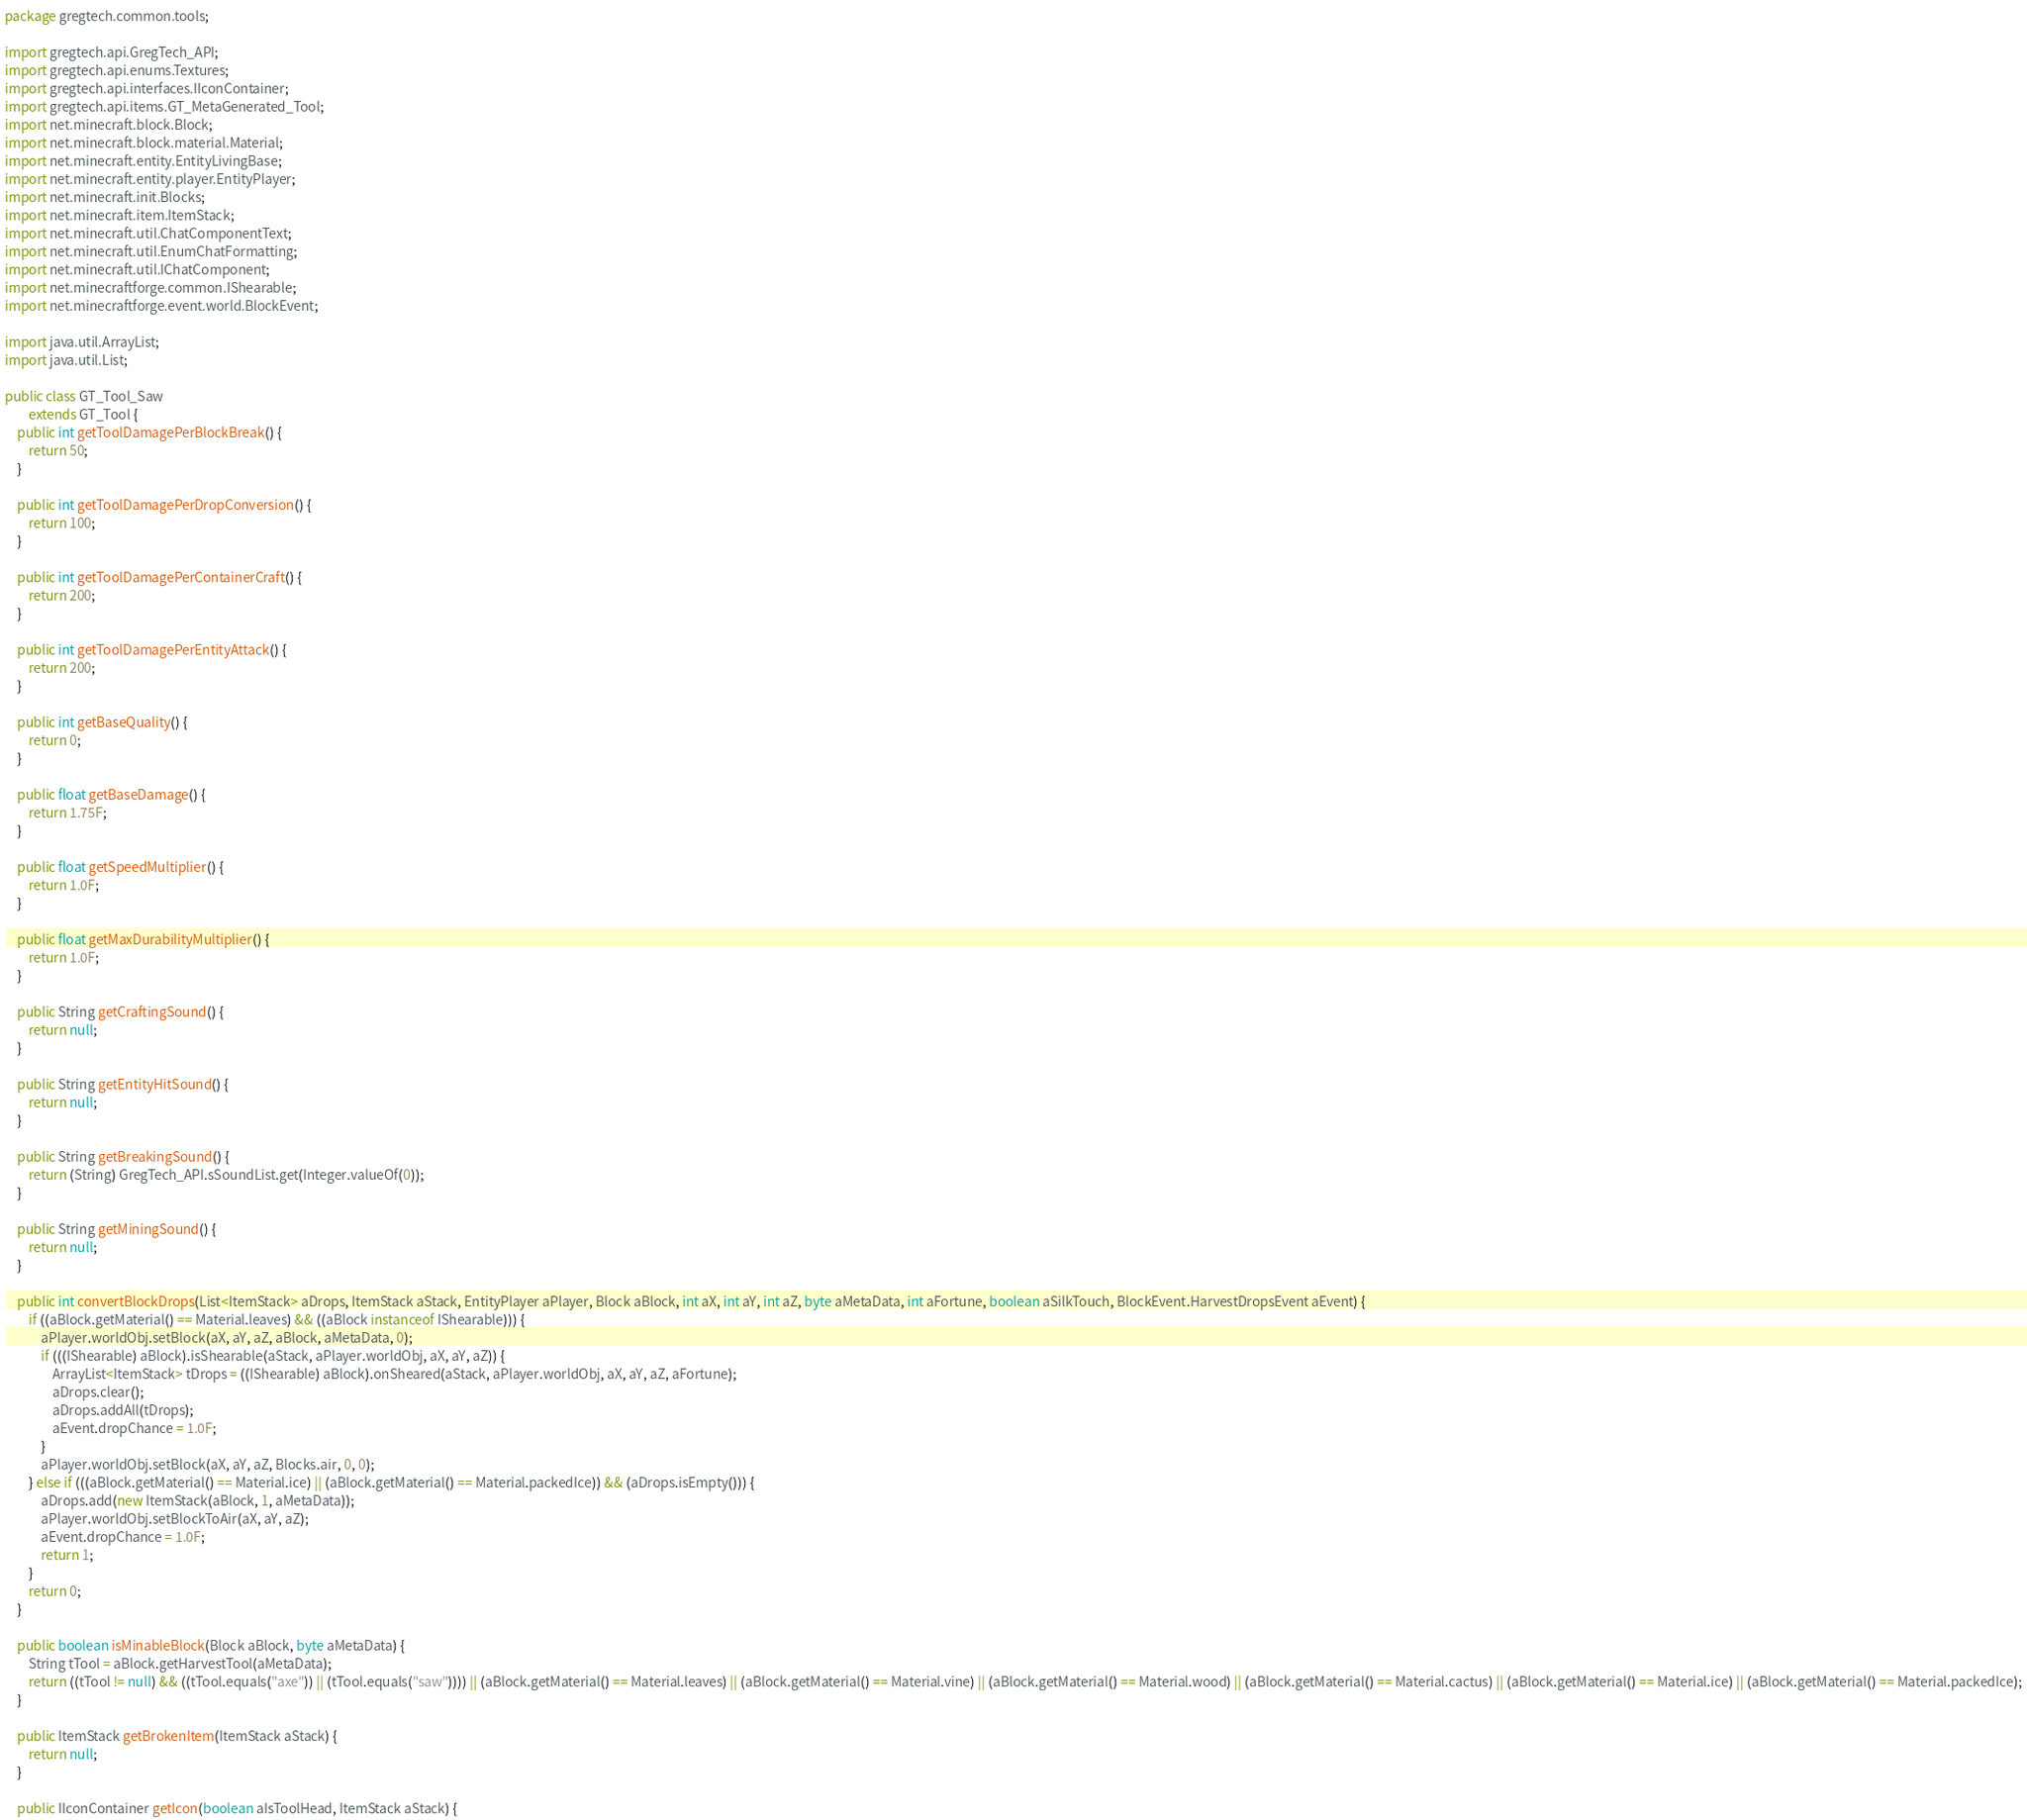<code> <loc_0><loc_0><loc_500><loc_500><_Java_>package gregtech.common.tools;

import gregtech.api.GregTech_API;
import gregtech.api.enums.Textures;
import gregtech.api.interfaces.IIconContainer;
import gregtech.api.items.GT_MetaGenerated_Tool;
import net.minecraft.block.Block;
import net.minecraft.block.material.Material;
import net.minecraft.entity.EntityLivingBase;
import net.minecraft.entity.player.EntityPlayer;
import net.minecraft.init.Blocks;
import net.minecraft.item.ItemStack;
import net.minecraft.util.ChatComponentText;
import net.minecraft.util.EnumChatFormatting;
import net.minecraft.util.IChatComponent;
import net.minecraftforge.common.IShearable;
import net.minecraftforge.event.world.BlockEvent;

import java.util.ArrayList;
import java.util.List;

public class GT_Tool_Saw
        extends GT_Tool {
    public int getToolDamagePerBlockBreak() {
        return 50;
    }

    public int getToolDamagePerDropConversion() {
        return 100;
    }

    public int getToolDamagePerContainerCraft() {
        return 200;
    }

    public int getToolDamagePerEntityAttack() {
        return 200;
    }

    public int getBaseQuality() {
        return 0;
    }

    public float getBaseDamage() {
        return 1.75F;
    }

    public float getSpeedMultiplier() {
        return 1.0F;
    }

    public float getMaxDurabilityMultiplier() {
        return 1.0F;
    }

    public String getCraftingSound() {
        return null;
    }

    public String getEntityHitSound() {
        return null;
    }

    public String getBreakingSound() {
        return (String) GregTech_API.sSoundList.get(Integer.valueOf(0));
    }

    public String getMiningSound() {
        return null;
    }

    public int convertBlockDrops(List<ItemStack> aDrops, ItemStack aStack, EntityPlayer aPlayer, Block aBlock, int aX, int aY, int aZ, byte aMetaData, int aFortune, boolean aSilkTouch, BlockEvent.HarvestDropsEvent aEvent) {
        if ((aBlock.getMaterial() == Material.leaves) && ((aBlock instanceof IShearable))) {
            aPlayer.worldObj.setBlock(aX, aY, aZ, aBlock, aMetaData, 0);
            if (((IShearable) aBlock).isShearable(aStack, aPlayer.worldObj, aX, aY, aZ)) {
                ArrayList<ItemStack> tDrops = ((IShearable) aBlock).onSheared(aStack, aPlayer.worldObj, aX, aY, aZ, aFortune);
                aDrops.clear();
                aDrops.addAll(tDrops);
                aEvent.dropChance = 1.0F;
            }
            aPlayer.worldObj.setBlock(aX, aY, aZ, Blocks.air, 0, 0);
        } else if (((aBlock.getMaterial() == Material.ice) || (aBlock.getMaterial() == Material.packedIce)) && (aDrops.isEmpty())) {
            aDrops.add(new ItemStack(aBlock, 1, aMetaData));
            aPlayer.worldObj.setBlockToAir(aX, aY, aZ);
            aEvent.dropChance = 1.0F;
            return 1;
        }
        return 0;
    }

    public boolean isMinableBlock(Block aBlock, byte aMetaData) {
        String tTool = aBlock.getHarvestTool(aMetaData);
        return ((tTool != null) && ((tTool.equals("axe")) || (tTool.equals("saw")))) || (aBlock.getMaterial() == Material.leaves) || (aBlock.getMaterial() == Material.vine) || (aBlock.getMaterial() == Material.wood) || (aBlock.getMaterial() == Material.cactus) || (aBlock.getMaterial() == Material.ice) || (aBlock.getMaterial() == Material.packedIce);
    }

    public ItemStack getBrokenItem(ItemStack aStack) {
        return null;
    }

    public IIconContainer getIcon(boolean aIsToolHead, ItemStack aStack) {</code> 